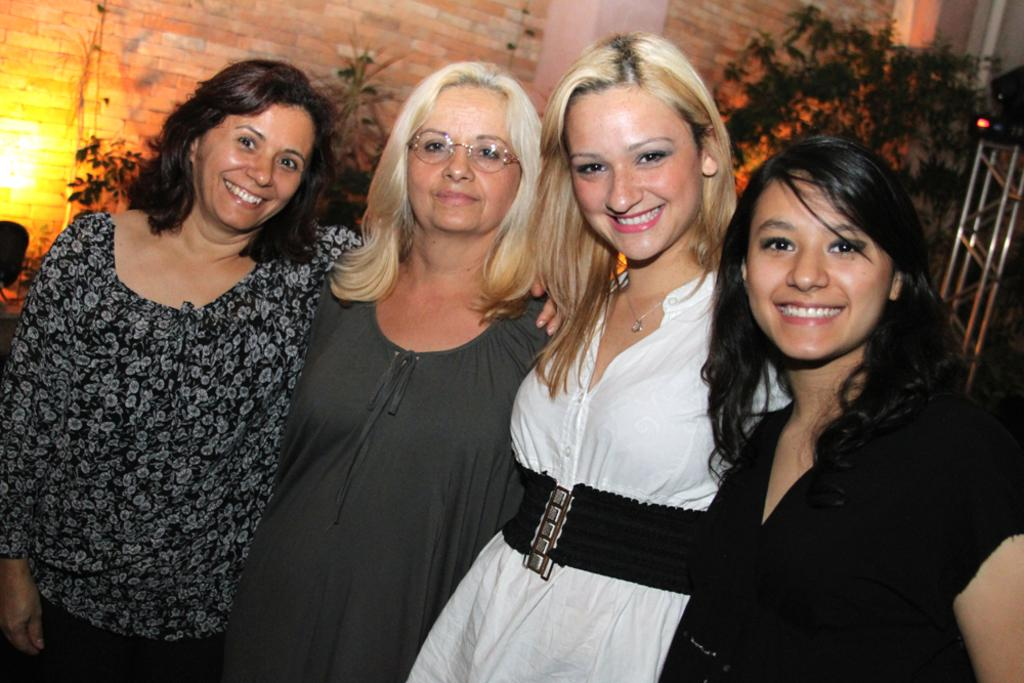How many women are in the image? There are four women in the image. Where are the women located in the image? The women are standing in the middle of the image. What is the facial expression of the women? The women are smiling. What are the women doing in the image? The women are posing for the camera. What can be seen in the background of the image? There is a brick wall and plants in the background of the image. What type of voice can be heard coming from the women in the image? There is no sound or voice present in the image, as it is a still photograph. 